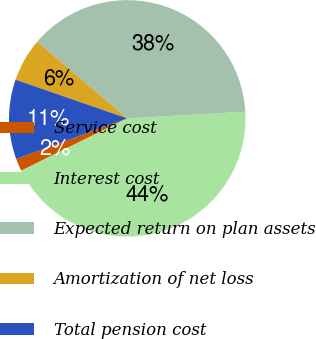<chart> <loc_0><loc_0><loc_500><loc_500><pie_chart><fcel>Service cost<fcel>Interest cost<fcel>Expected return on plan assets<fcel>Amortization of net loss<fcel>Total pension cost<nl><fcel>1.72%<fcel>43.6%<fcel>37.89%<fcel>5.91%<fcel>10.88%<nl></chart> 